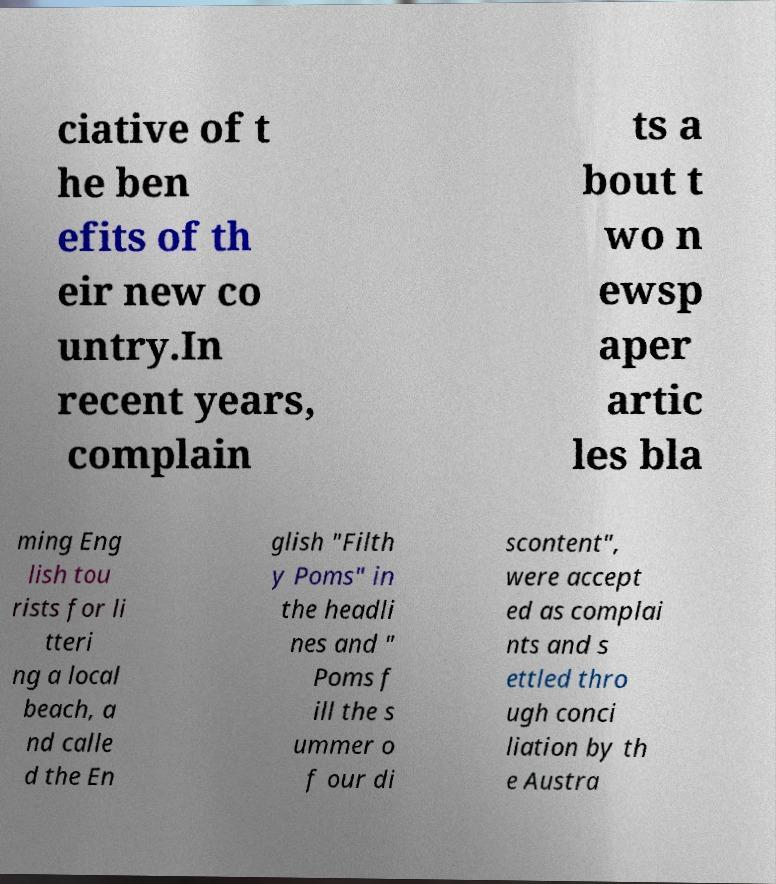I need the written content from this picture converted into text. Can you do that? ciative of t he ben efits of th eir new co untry.In recent years, complain ts a bout t wo n ewsp aper artic les bla ming Eng lish tou rists for li tteri ng a local beach, a nd calle d the En glish "Filth y Poms" in the headli nes and " Poms f ill the s ummer o f our di scontent", were accept ed as complai nts and s ettled thro ugh conci liation by th e Austra 